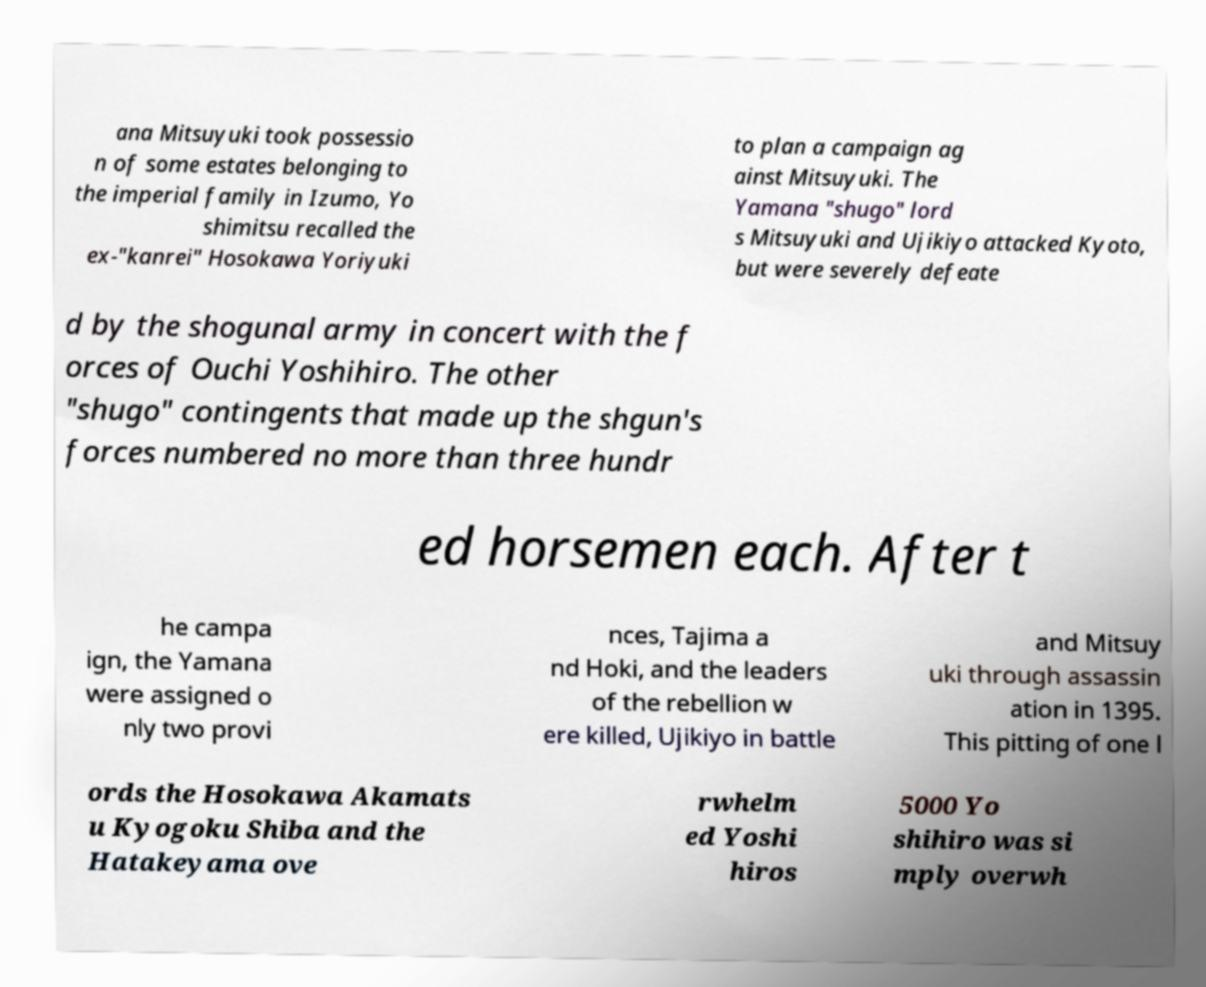I need the written content from this picture converted into text. Can you do that? ana Mitsuyuki took possessio n of some estates belonging to the imperial family in Izumo, Yo shimitsu recalled the ex-"kanrei" Hosokawa Yoriyuki to plan a campaign ag ainst Mitsuyuki. The Yamana "shugo" lord s Mitsuyuki and Ujikiyo attacked Kyoto, but were severely defeate d by the shogunal army in concert with the f orces of Ouchi Yoshihiro. The other "shugo" contingents that made up the shgun's forces numbered no more than three hundr ed horsemen each. After t he campa ign, the Yamana were assigned o nly two provi nces, Tajima a nd Hoki, and the leaders of the rebellion w ere killed, Ujikiyo in battle and Mitsuy uki through assassin ation in 1395. This pitting of one l ords the Hosokawa Akamats u Kyogoku Shiba and the Hatakeyama ove rwhelm ed Yoshi hiros 5000 Yo shihiro was si mply overwh 